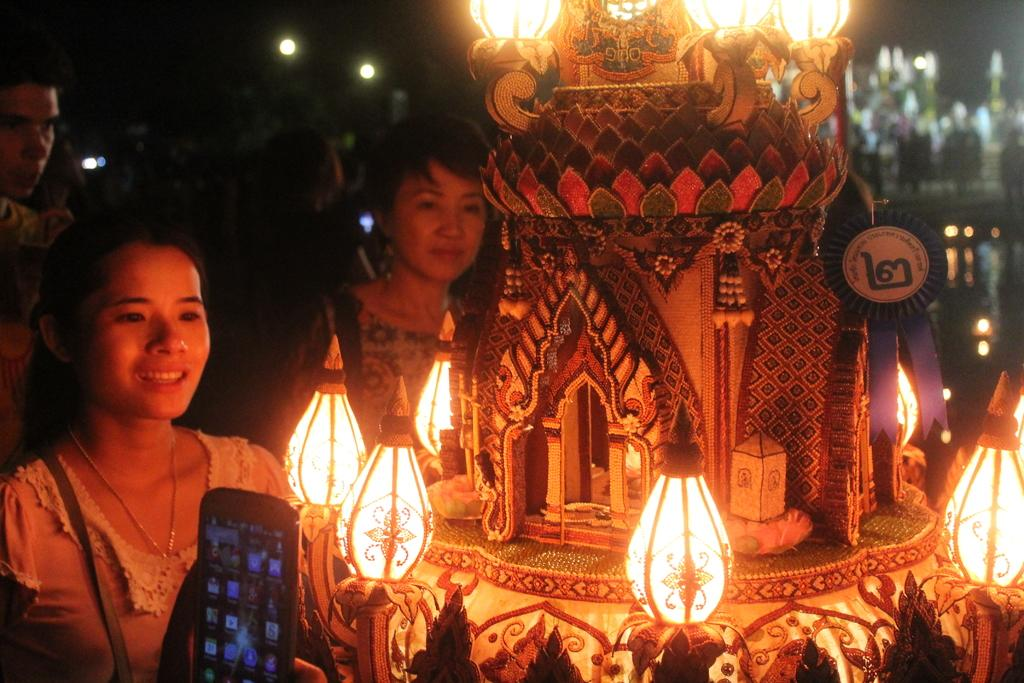Who or what can be seen in the image? There are people in the image. What are the people doing in the image? The people are standing in front of a decorated object. Can you describe the decorated object? The decorated object is covered with lights. Is there any rain visible in the image? No, there is no rain visible in the image. What type of apparatus is being used by the people in the image? There is no specific apparatus mentioned or visible in the image; the people are simply standing in front of a decorated object. 